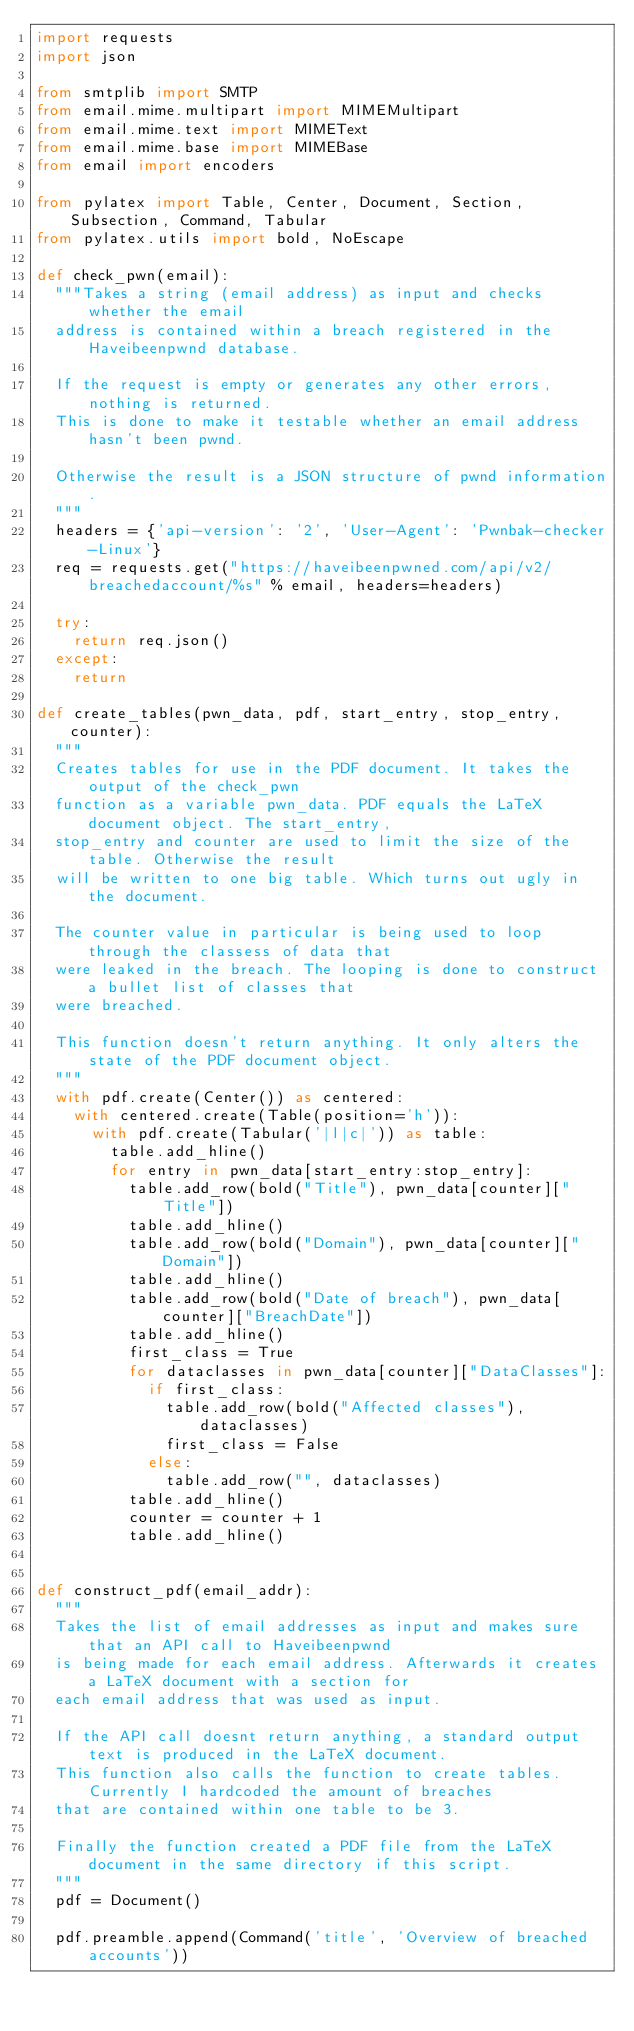<code> <loc_0><loc_0><loc_500><loc_500><_Python_>import requests
import json

from smtplib import SMTP
from email.mime.multipart import MIMEMultipart
from email.mime.text import MIMEText
from email.mime.base import MIMEBase
from email import encoders

from pylatex import Table, Center, Document, Section, Subsection, Command, Tabular
from pylatex.utils import bold, NoEscape

def check_pwn(email):
	"""Takes a string (email address) as input and checks whether the email
	address is contained within a breach registered in the Haveibeenpwnd database.

	If the request is empty or generates any other errors, nothing is returned.
	This is done to make it testable whether an email address hasn't been pwnd.

	Otherwise the result is a JSON structure of pwnd information.
	"""
	headers = {'api-version': '2', 'User-Agent': 'Pwnbak-checker-Linux'}
	req = requests.get("https://haveibeenpwned.com/api/v2/breachedaccount/%s" % email, headers=headers)
	
	try:
		return req.json()
	except:
		return

def create_tables(pwn_data, pdf, start_entry, stop_entry, counter):
	"""
	Creates tables for use in the PDF document. It takes the output of the check_pwn
	function as a variable pwn_data. PDF equals the LaTeX document object. The start_entry,
	stop_entry and counter are used to limit the size of the table. Otherwise the result
	will be written to one big table. Which turns out ugly in the document.

	The counter value in particular is being used to loop through the classess of data that
	were leaked in the breach. The looping is done to construct a bullet list of classes that
	were breached.

	This function doesn't return anything. It only alters the state of the PDF document object.
	"""
	with pdf.create(Center()) as centered:
		with centered.create(Table(position='h')):
			with pdf.create(Tabular('|l|c|')) as table:
				table.add_hline()
				for entry in pwn_data[start_entry:stop_entry]:
					table.add_row(bold("Title"), pwn_data[counter]["Title"]) 
					table.add_hline()
					table.add_row(bold("Domain"), pwn_data[counter]["Domain"])
					table.add_hline()
					table.add_row(bold("Date of breach"), pwn_data[counter]["BreachDate"])
					table.add_hline()
					first_class = True
					for dataclasses in pwn_data[counter]["DataClasses"]:
						if first_class:
							table.add_row(bold("Affected classes"), dataclasses)
							first_class = False
						else:
							table.add_row("", dataclasses)
					table.add_hline()
					counter = counter + 1
					table.add_hline()


def construct_pdf(email_addr):
	"""
	Takes the list of email addresses as input and makes sure that an API call to Haveibeenpwnd
	is being made for each email address. Afterwards it creates a LaTeX document with a section for
	each email address that was used as input. 

	If the API call doesnt return anything, a standard output text is produced in the LaTeX document.
	This function also calls the function to create tables. Currently I hardcoded the amount of breaches
	that are contained within one table to be 3.

	Finally the function created a PDF file from the LaTeX document in the same directory if this script.
	"""
	pdf = Document()

	pdf.preamble.append(Command('title', 'Overview of breached accounts'))</code> 